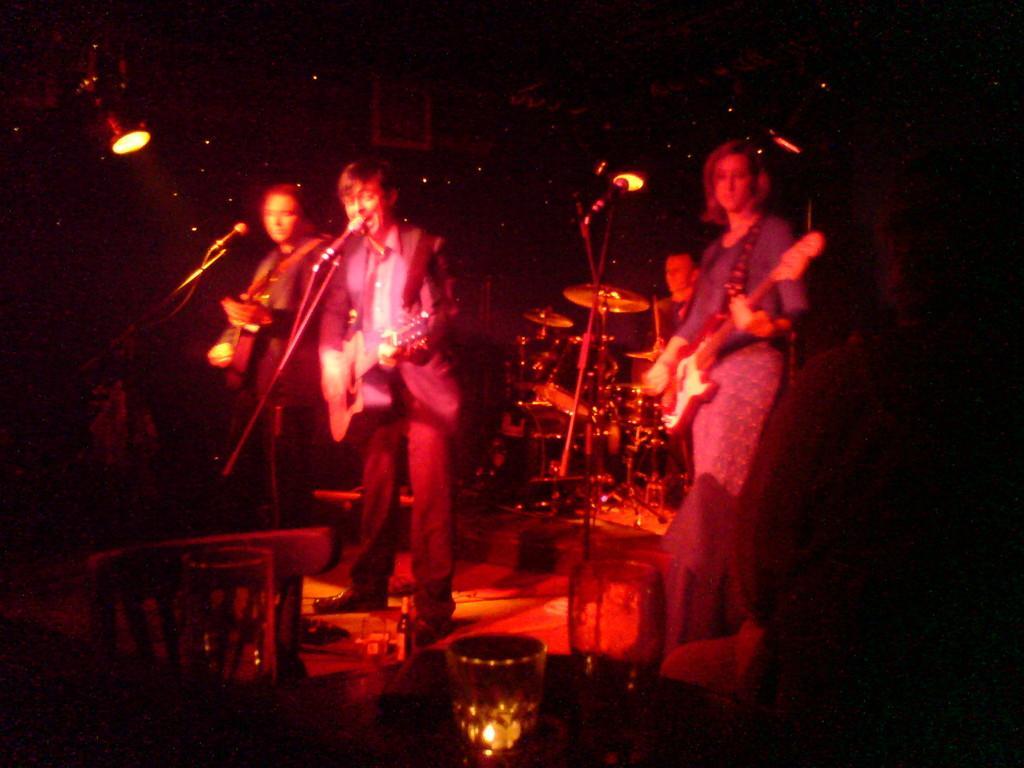Describe this image in one or two sentences. In this picture i could see the persons performing a musical show they are holding guitar in there hands in the background its too dark and some flash lights are around. In the bottom of the picture i could see candle in the glass. 